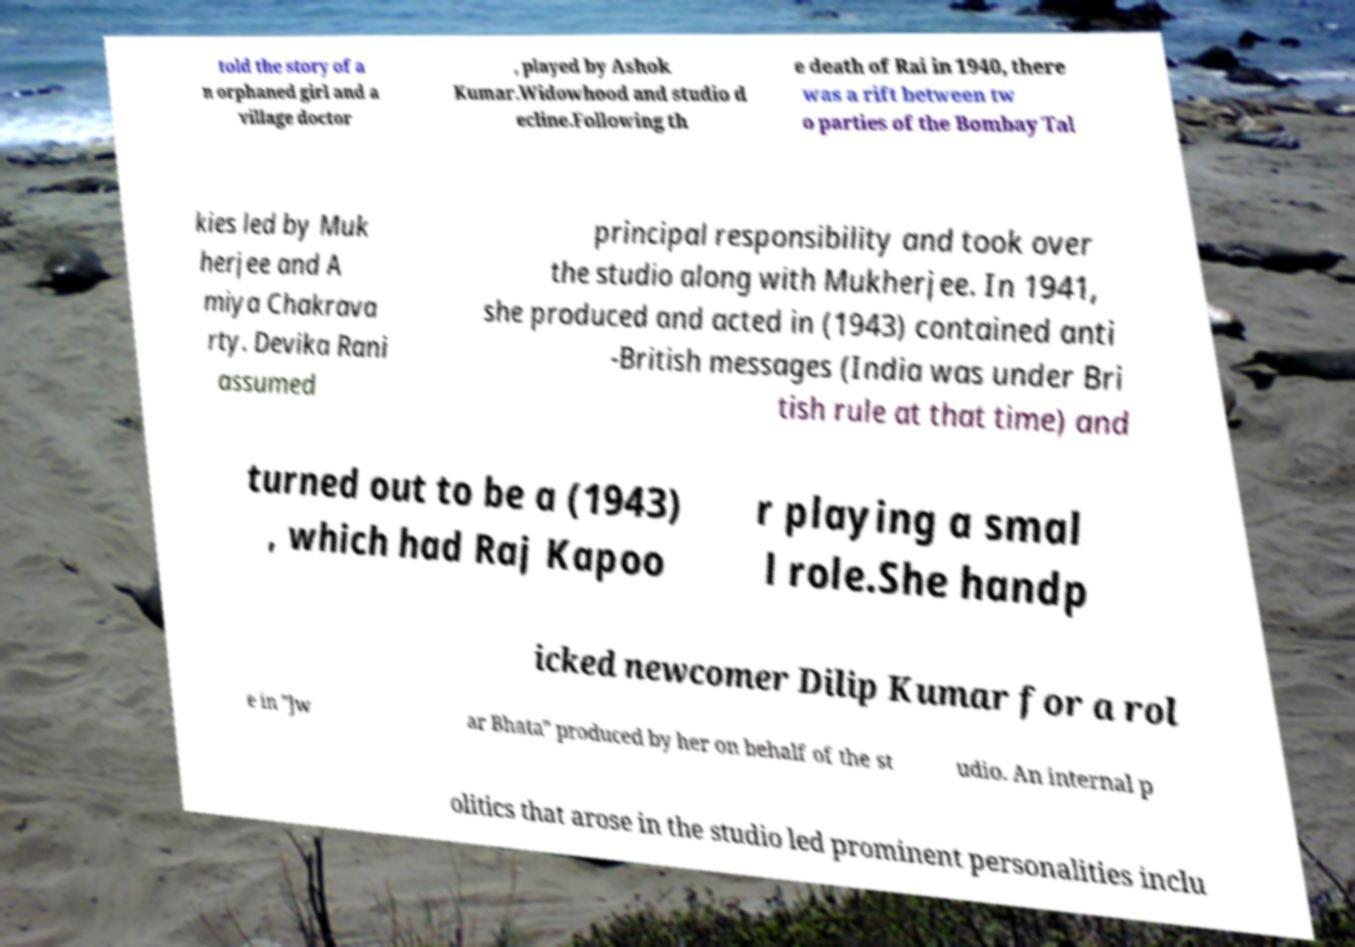There's text embedded in this image that I need extracted. Can you transcribe it verbatim? told the story of a n orphaned girl and a village doctor , played by Ashok Kumar.Widowhood and studio d ecline.Following th e death of Rai in 1940, there was a rift between tw o parties of the Bombay Tal kies led by Muk herjee and A miya Chakrava rty. Devika Rani assumed principal responsibility and took over the studio along with Mukherjee. In 1941, she produced and acted in (1943) contained anti -British messages (India was under Bri tish rule at that time) and turned out to be a (1943) , which had Raj Kapoo r playing a smal l role.She handp icked newcomer Dilip Kumar for a rol e in "Jw ar Bhata" produced by her on behalf of the st udio. An internal p olitics that arose in the studio led prominent personalities inclu 